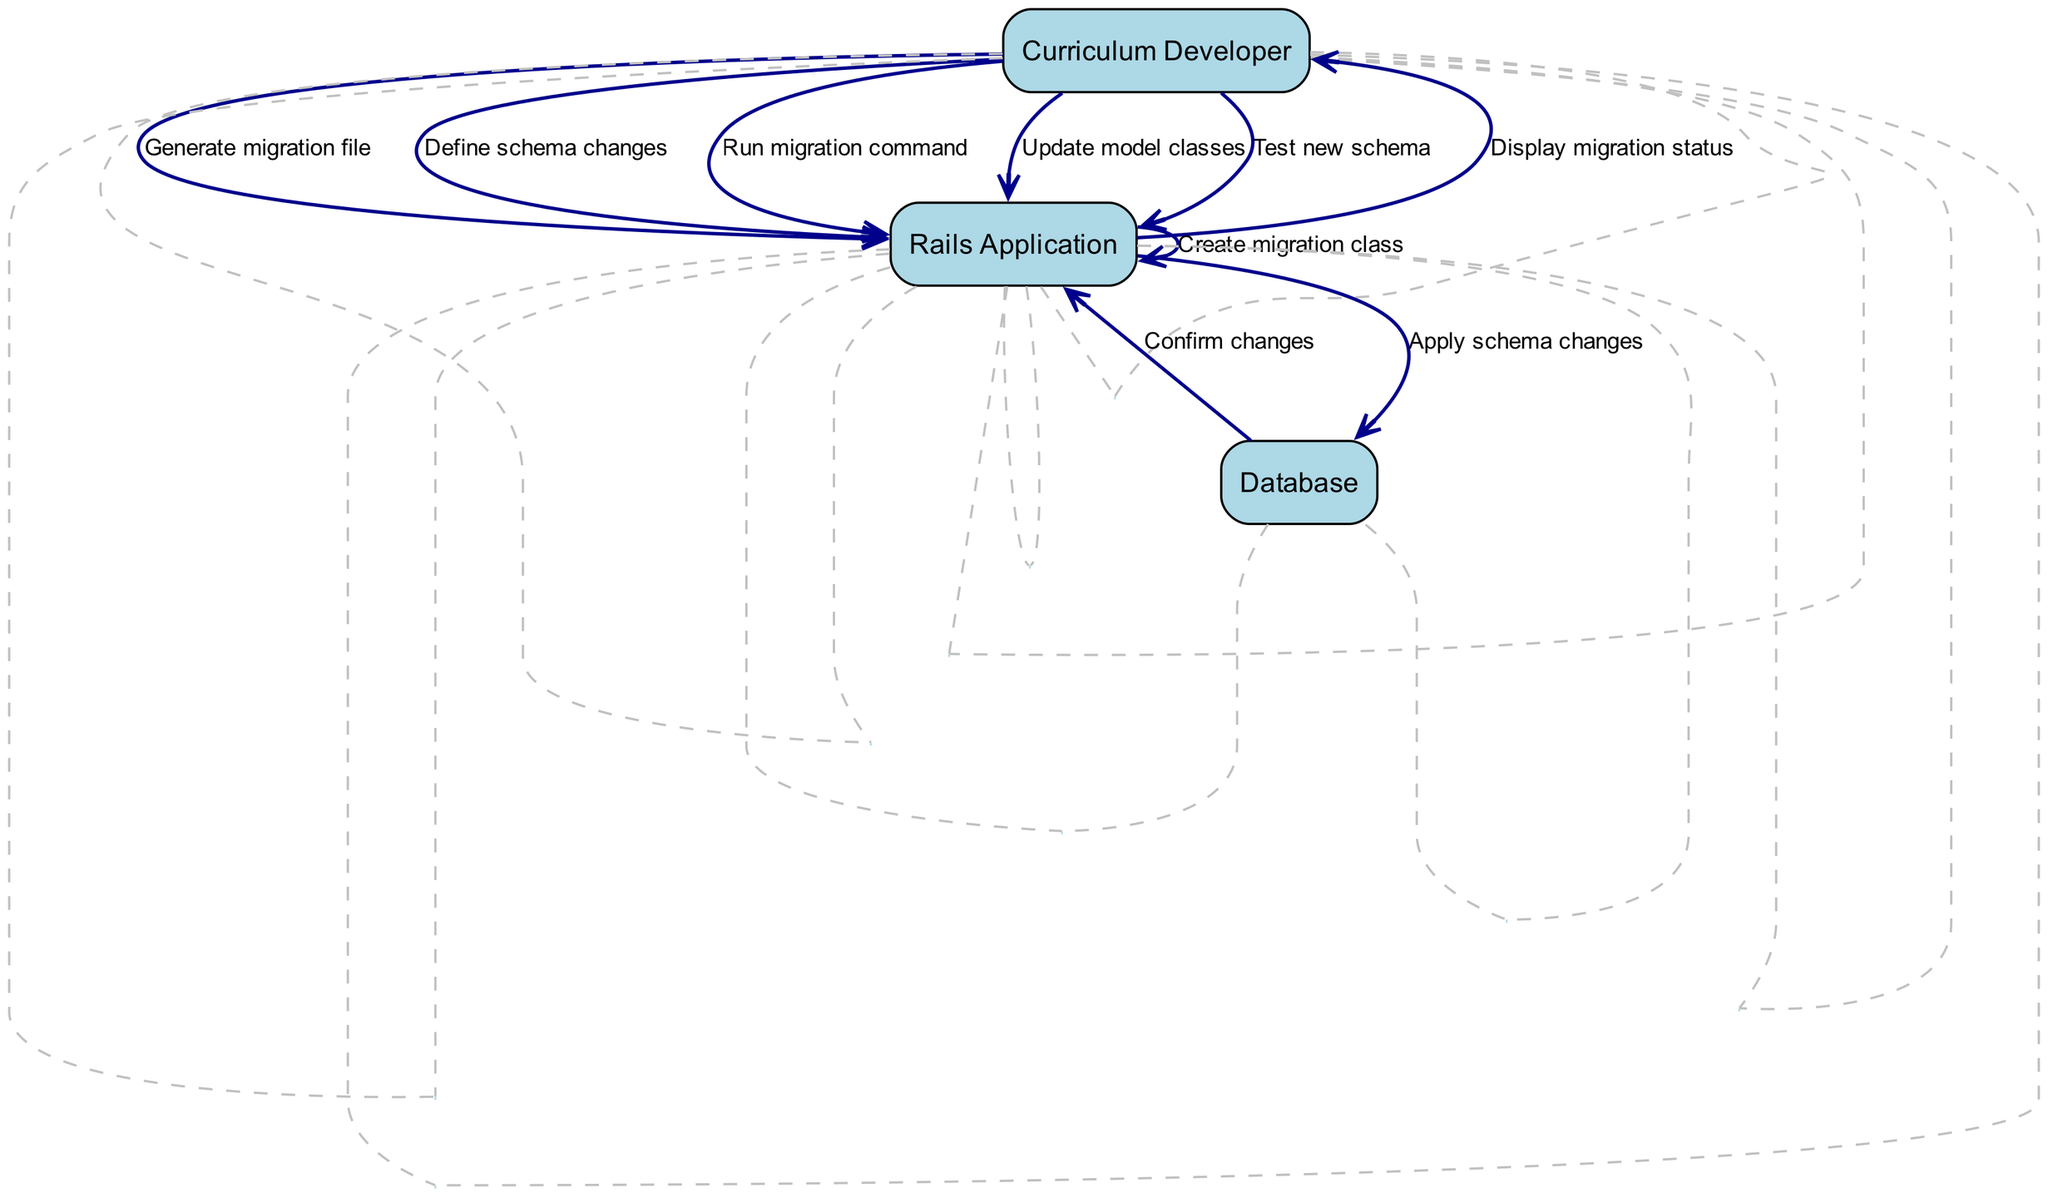What is the first action taken in the sequence? The sequence starts with the "Curriculum Developer" generating a migration file, which is the first action indicated in the diagram.
Answer: Generate migration file How many main actors are involved in the process? The diagram identifies three main actors: "Curriculum Developer," "Rails Application," and "Database." Therefore, the total count of main actors is three.
Answer: 3 What action does the "Rails Application" take after creating the migration class? Following the creation of the migration class, the next action by the "Rails Application" is to apply the schema changes. This is the action that directly follows the creation of the migration class in the sequence.
Answer: Apply schema changes Which actor displays the migration status? The "Rails Application" is responsible for displaying the migration status to the "Curriculum Developer." This can be observed as the action where the Rails Application communicates the status back to the Curriculum Developer.
Answer: Rails Application What is the last action performed in the sequence? The last action noted in the sequence is the "Curriculum Developer" testing the new schema. This action is positioned at the end of the sequence flow, indicating the completion of the process.
Answer: Test new schema Which action comes directly after defining the schema changes? After the "Curriculum Developer" defines the schema changes, the next action taken is to run the migration command. This provides a direct follow-up from the definition of changes to executing them.
Answer: Run migration command How many actions are initiated by the "Curriculum Developer"? The "Curriculum Developer" initiates four actions according to the sequence: generating a migration file, defining schema changes, running the migration command, and updating model classes. Summing these gives us the total.
Answer: 4 What does the "Database" do after receiving schema changes? Upon receiving the schema changes, the "Database" confirms the changes made. This is the immediate response from the Database after applying the changes, indicating it has completed processing them.
Answer: Confirm changes 